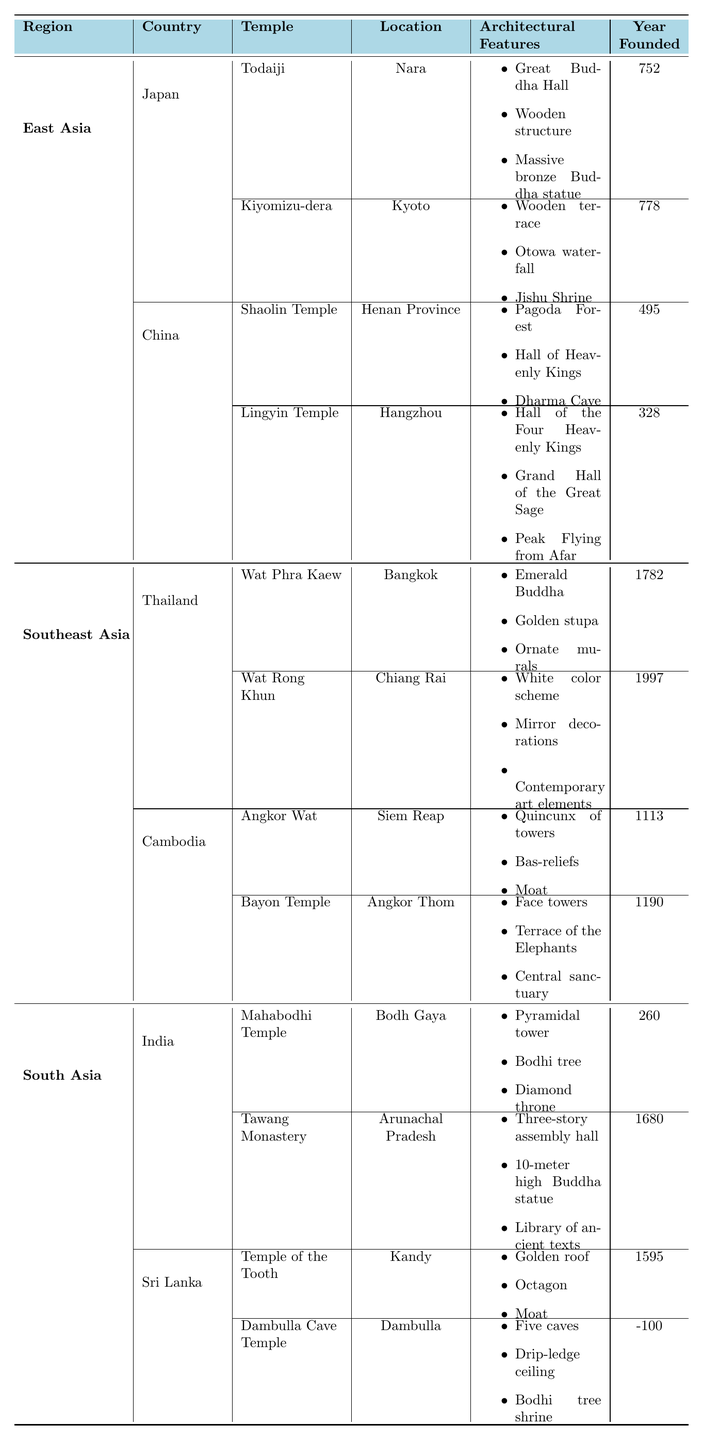What is the historical significance of Angkor Wat? The historical significance of Angkor Wat is that it is the largest religious monument in the world, which is explicitly stated in the table under "Historical Significance."
Answer: Largest religious monument in the world Which temple is located in Kandy? According to the table, the Temple of the Tooth is located in Kandy, as indicated in the respective row and column for Sri Lanka.
Answer: Temple of the Tooth How many temples are there in Japan according to the table? In the table, there are two temples listed under Japan: Todaiji and Kiyomizu-dera, counted by referring to the "Temples" section under Japan's entry.
Answer: 2 Which region has the most recent temple founded, and what is its name? The most recent temple founded is Wat Rong Khun in Thailand, established in 1997. This information is found by comparing the "Year Founded" values across all entries in the table.
Answer: Wat Rong Khun Is the Mahabodhi Temple the site of Buddha's enlightenment? Yes, the table clearly states that the historical significance of Mahabodhi Temple is that it is the site of Buddha's enlightenment.
Answer: Yes What architectural features are common between the temples in Thailand? Both Wat Phra Kaew and Wat Rong Khun have unique architectural features, such as ornate murals and contemporary art elements respectively. However, none are common. Therefore, explicitly summarizing the features points out the differences rather than commonalities.
Answer: None Which country has the oldest temple, and what is its name? The oldest temple listed is Dambulla Cave Temple in Sri Lanka, with a year founded of -100, which you can find by identifying the minimum value in the "Year Founded" column.
Answer: Dambulla Cave Temple, Sri Lanka What is the average year founded of temples in South Asia? To calculate the average year founded, we first sum up the years: 260 (Mahabodhi) + 1680 (Tawang) + 1595 (Temple of the Tooth) + (-100) (Dambulla) = 3435. We then divide by the number of temples, which is 4, resulting in an average of 3435 / 4 = 858.75.
Answer: 858.75 Which temple has the most elaborate architectural features according to the table? The table specifies various architectural features for each temple, and while subjective, Wat Phra Kaew has a rich description with features such as Emerald Buddha, golden stupa, and ornate murals making it seem quite elaborate.
Answer: Wat Phra Kaew Which temple in China is known as the birthplace of Chan Buddhism? The Shaolin Temple is known as the birthplace of Chan Buddhism, a fact mentioned directly in the "Historical Significance" section of the table.
Answer: Shaolin Temple 